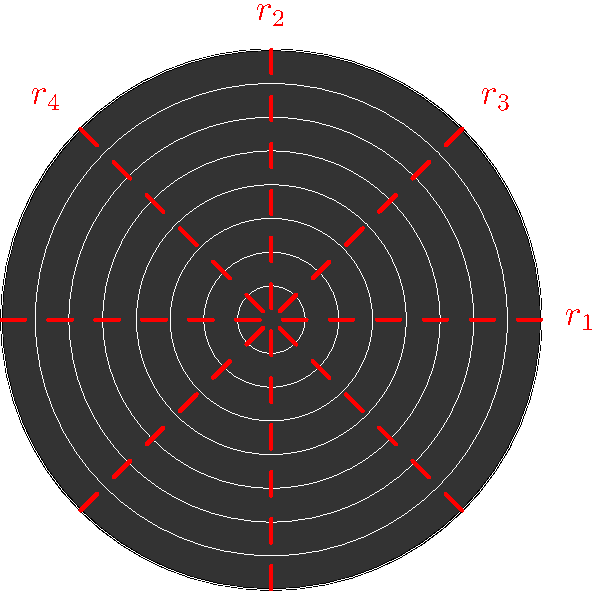As a former disco DJ, you're familiar with vinyl records. Consider the symmetry group of a typical vinyl record pattern, as shown in the diagram. The red dashed lines represent reflection axes. How many elements are in the symmetry group of this vinyl record pattern? Let's analyze the symmetry group step-by-step:

1. Rotational symmetry:
   - The record has 360° rotational symmetry (identity)
   - It also has 180° rotational symmetry
   - 90° and 270° rotational symmetries are also present
   Total rotational symmetries: 4

2. Reflection symmetry:
   - There are 4 reflection axes (labeled $r_1$, $r_2$, $r_3$, and $r_4$ in the diagram)
   Total reflection symmetries: 4

3. Combining rotations and reflections:
   - The identity element (360° rotation or no transformation)
   - 3 rotations (90°, 180°, 270°)
   - 4 reflections

To find the total number of elements in the symmetry group, we sum up all these transformations:

Total elements = 1 (identity) + 3 (rotations) + 4 (reflections) = 8

This symmetry group is known as the dihedral group $D_4$, which has 8 elements.
Answer: 8 